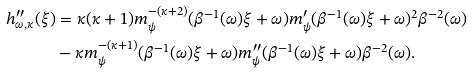Convert formula to latex. <formula><loc_0><loc_0><loc_500><loc_500>h _ { \omega , \kappa } ^ { \prime \prime } ( \xi ) & = \kappa ( \kappa + 1 ) m _ { \psi } ^ { - ( \kappa + 2 ) } ( \beta ^ { - 1 } ( \omega ) \xi + \omega ) m _ { \psi } ^ { \prime } ( \beta ^ { - 1 } ( \omega ) \xi + \omega ) ^ { 2 } \beta ^ { - 2 } ( \omega ) \\ & - \kappa m _ { \psi } ^ { - ( \kappa + 1 ) } ( \beta ^ { - 1 } ( \omega ) \xi + \omega ) m _ { \psi } ^ { \prime \prime } ( \beta ^ { - 1 } ( \omega ) \xi + \omega ) \beta ^ { - 2 } ( \omega ) .</formula> 